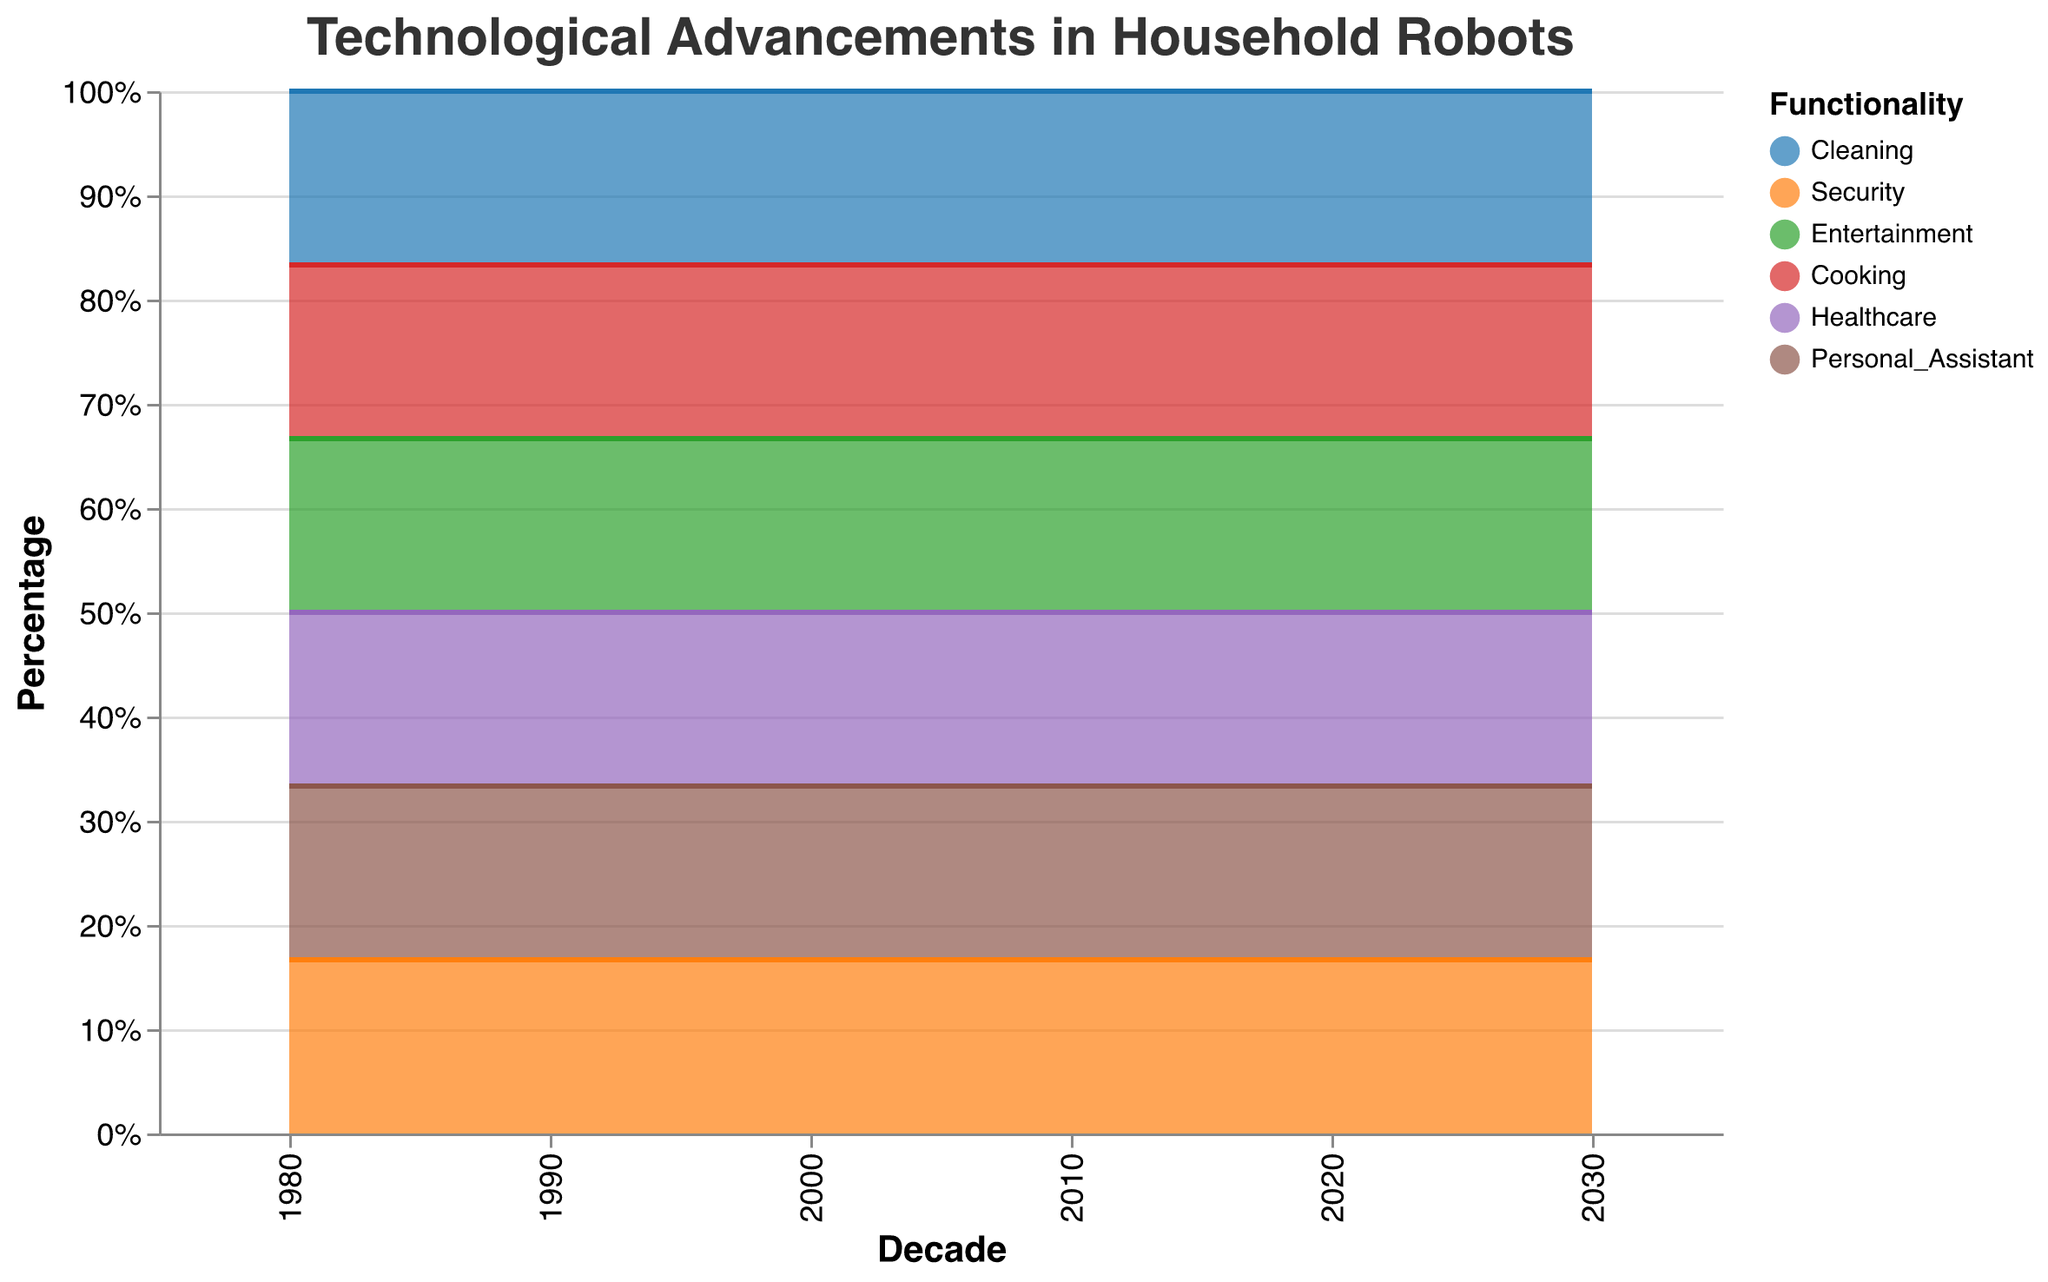What is the title of the chart? The title of the chart can be easily found at the top of the figure, it's visually prominent and typically provides a summary of the content.
Answer: Technological Advancements in Household Robots Which decade shows the highest percentage of Cleaning robots? Look at each segment corresponding to Cleaning robots over different decades and identify the one with the largest segment.
Answer: 1980 How has the percentage of Cleaning robots changed from 1980 to 2030? Observe the segments corresponding to Cleaning robots in 1980 and 2030, and note the change in their size as a percentage. Cleaning robots decreased steadily over years. In 1980 it was 50%, and by 2030 it dropped to 10%.
Answer: Decreased by 40% Which functionality sees an increasing trend between 2000 and 2030? Identify the functionalities with an upward trend in their segments from 2000 to 2030.
Answer: Cooking and Healthcare Between which decades does Personal Assistant functionality show a decrease? Track the size of the segments associated with Personal Assistant robots across decades and identify where a decrease occurs.
Answer: 1980 to 1990 Which functionality had no presence in 1980 but grew in later decades? Look at the segments in 1980; identify which were absent and later appeared.
Answer: Security and Healthcare Compare the percentage of Entertainment and Cooking robots in 2020. Which one is higher? Observe the segments corresponding to Entertainment and Cooking in the year 2020; compare their sizes to find which is larger.
Answer: Cooking What percentage of robots were used for Security in 2010? Find the segment corresponding to Security in 2010 and read off its percentage.
Answer: 20% What major trend is seen for Cleaning and Cooking robots between 1980 and 2030? Analyze the trends for Cleaning and Cooking segments over the decades. Notice the Cleaning segment decreases while the Cooking segment increases.
Answer: Cleaning decreases, Cooking increases 